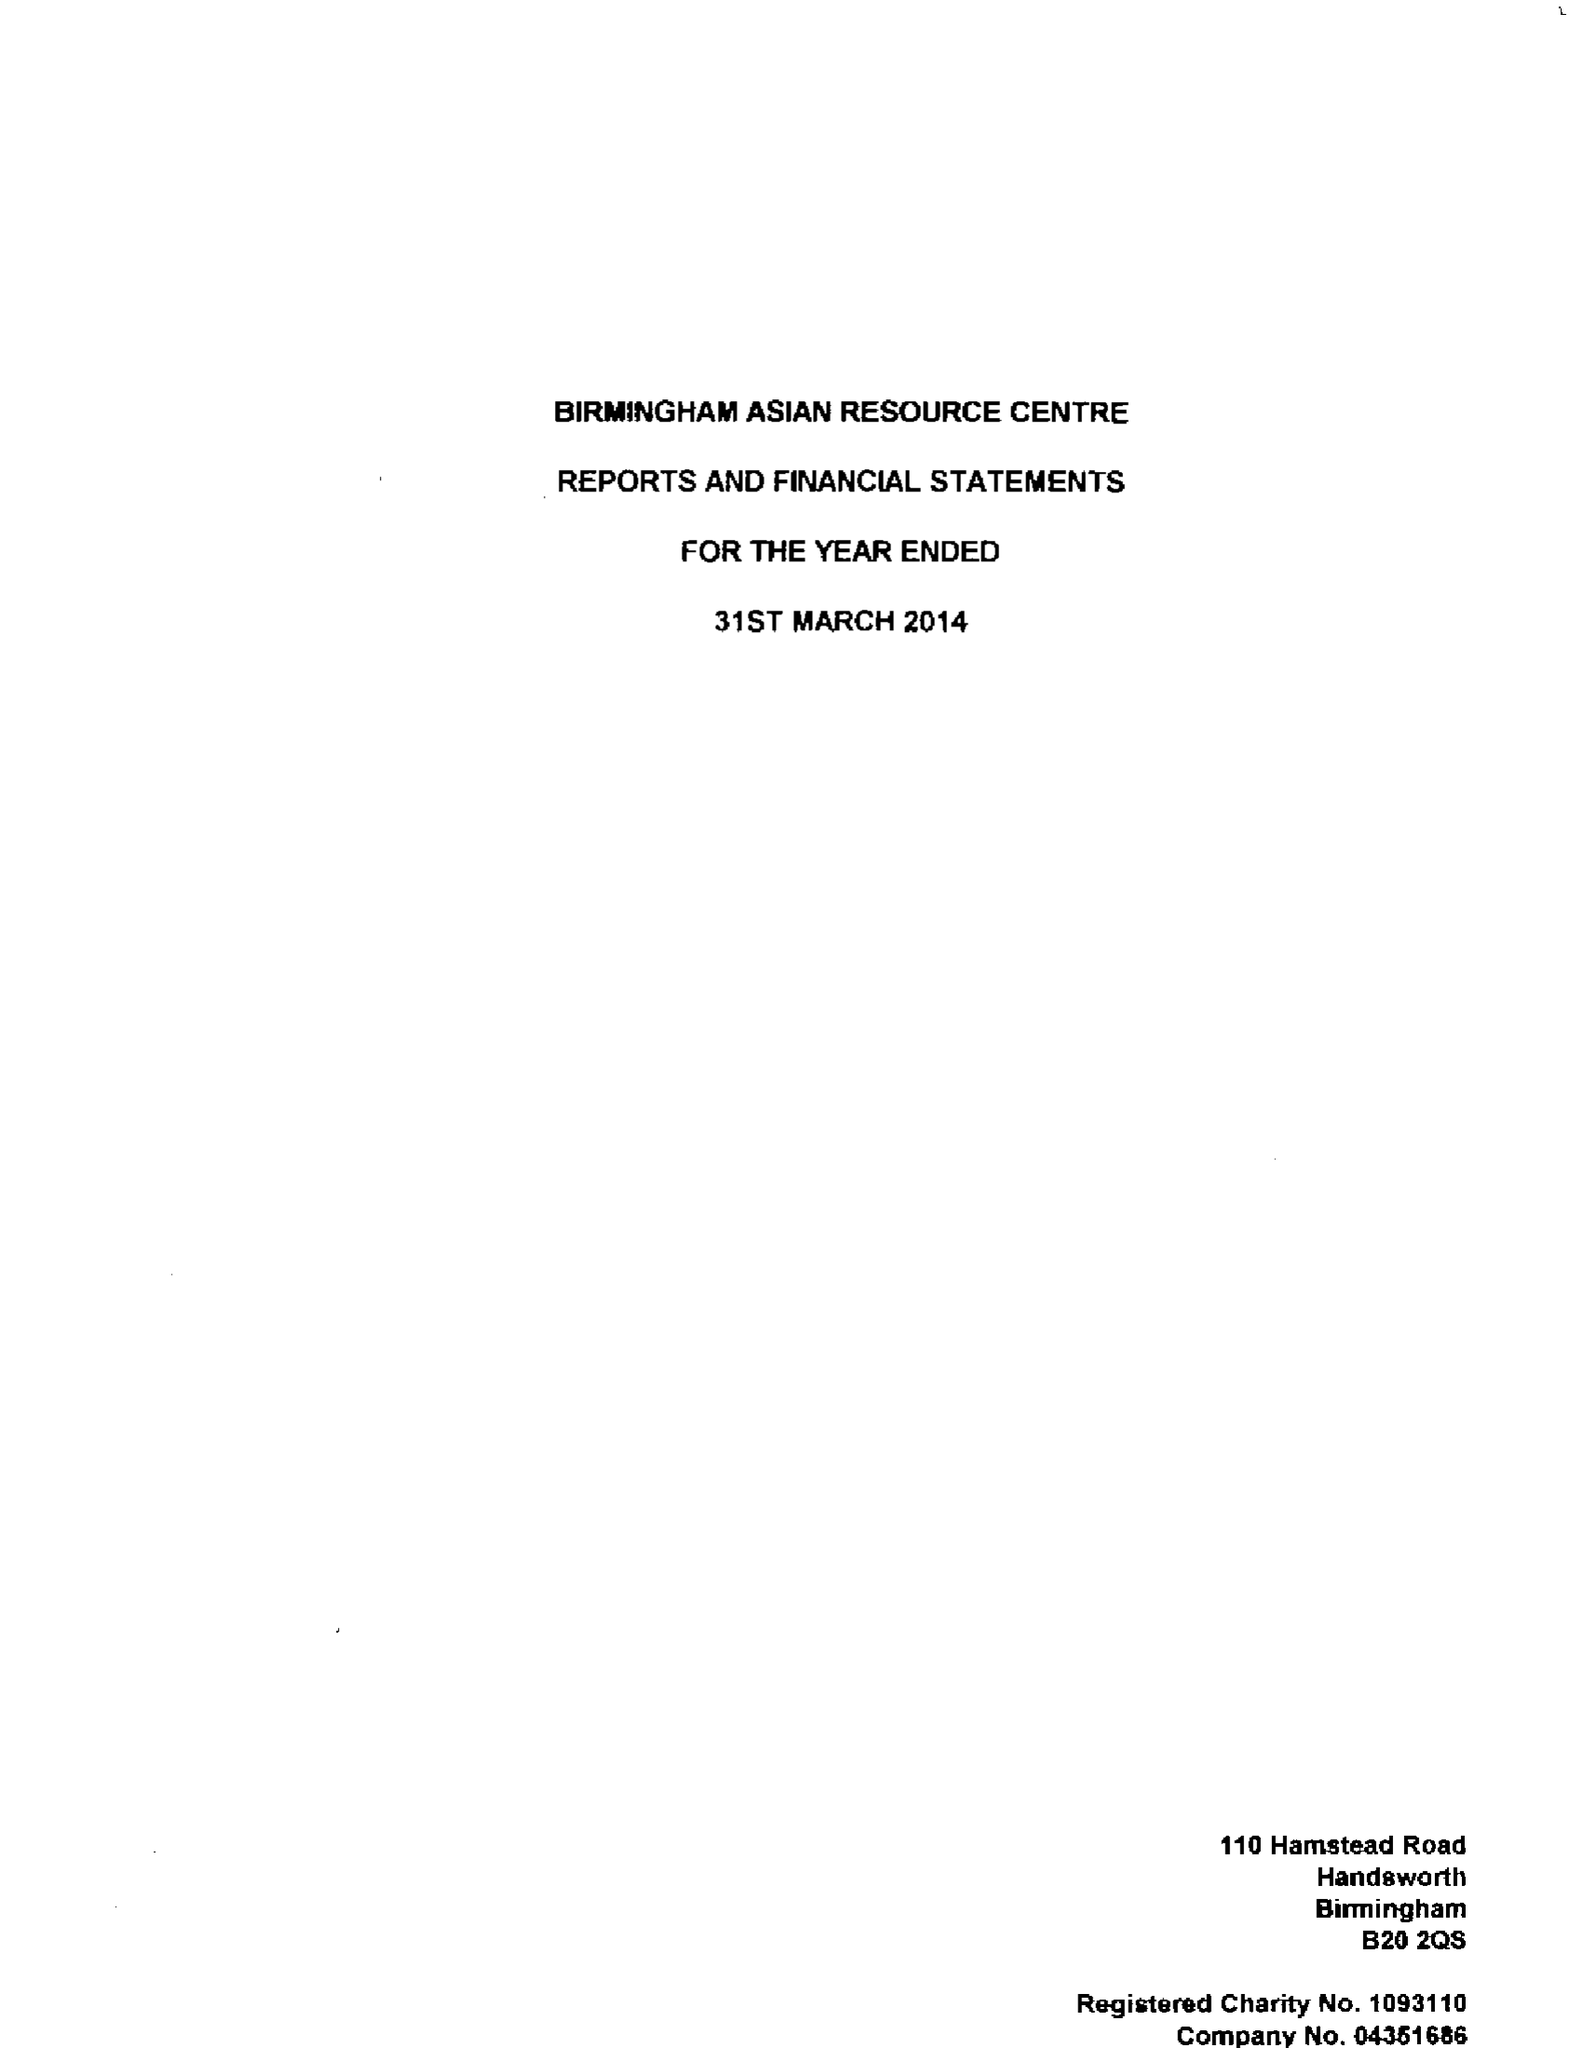What is the value for the address__post_town?
Answer the question using a single word or phrase. BIRMINGHAM 